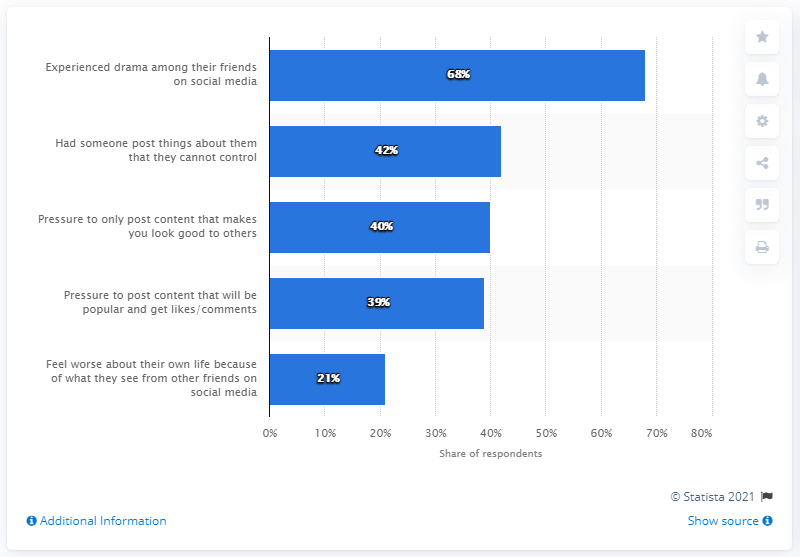List a handful of essential elements in this visual. The combined percentage of the last two forms of peer pressure is 60%. The second most popular type of peer pressure is when someone posts things about another person that they cannot control. 